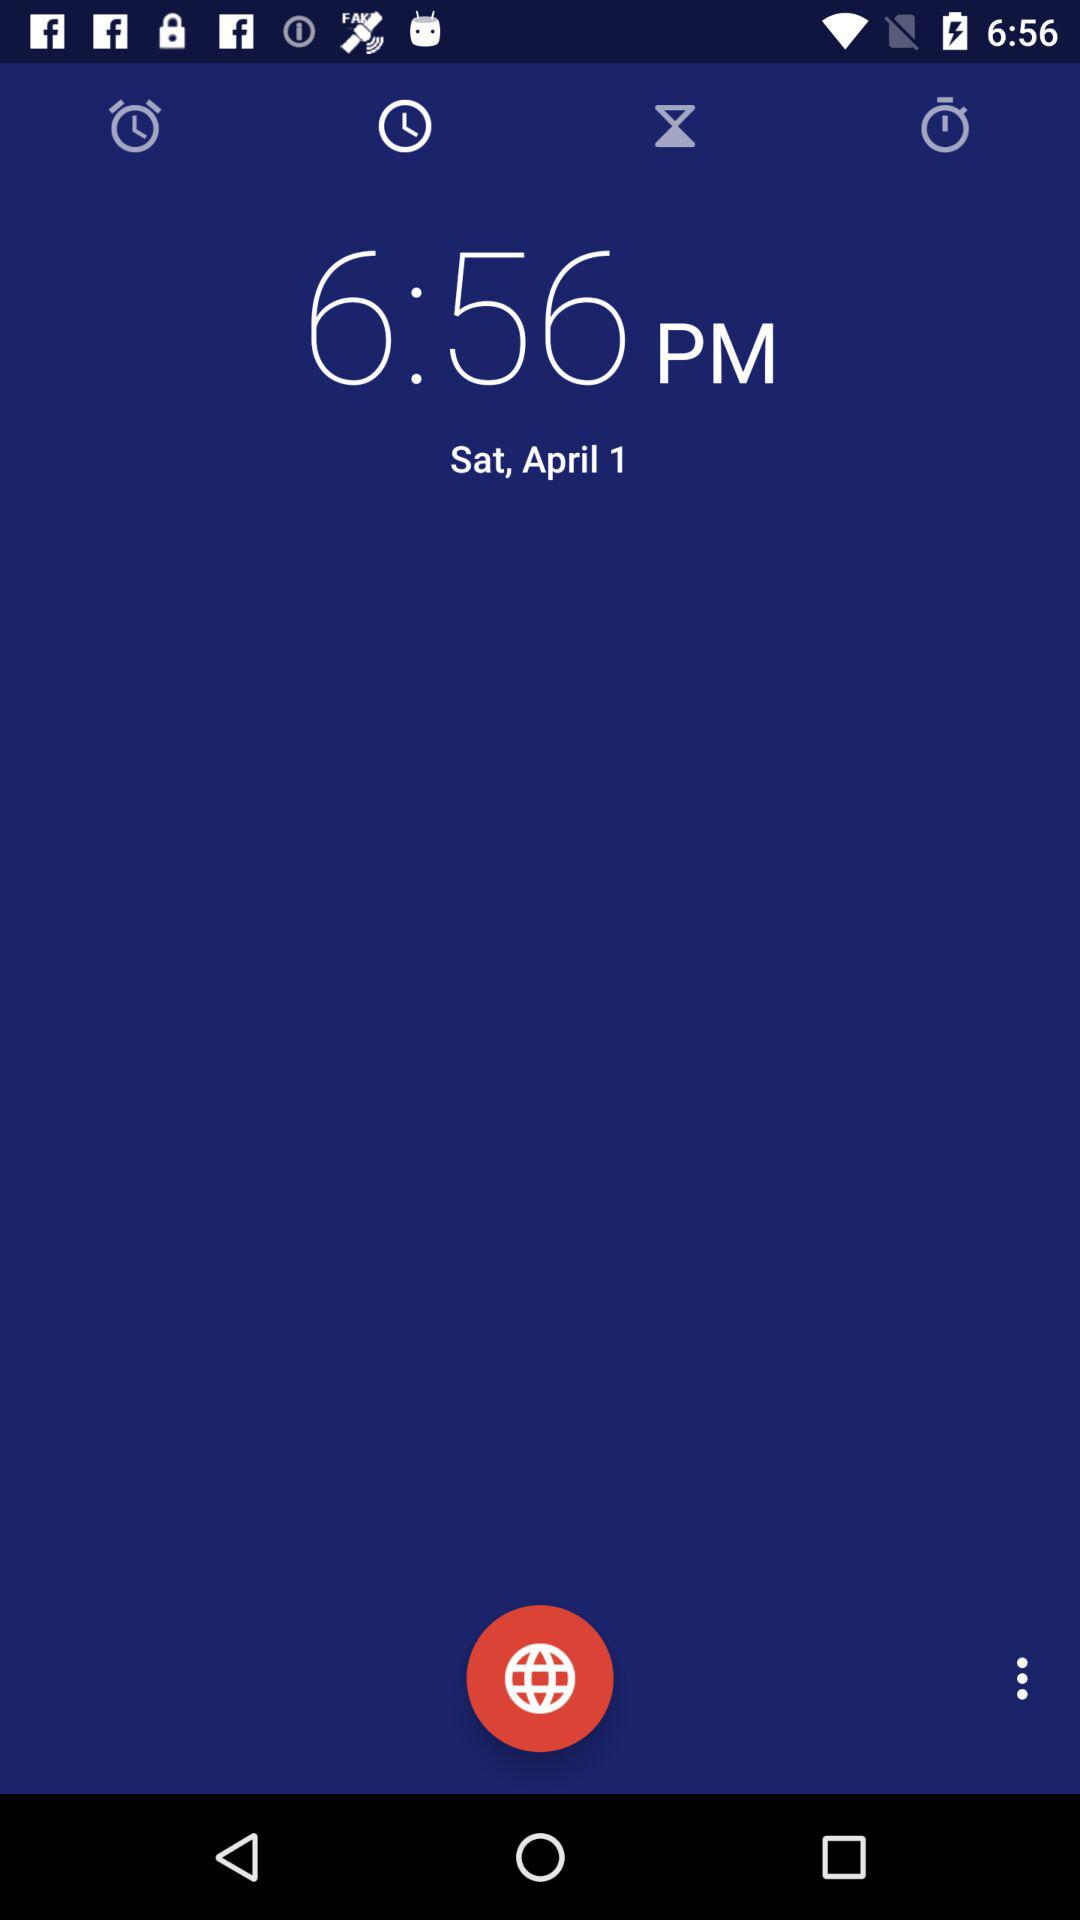What is the mentioned time? The mentioned time is 6:56 p.m. 